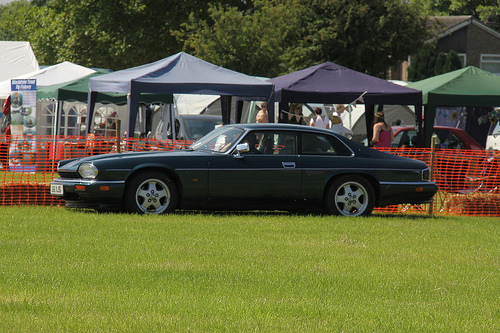<image>
Can you confirm if the orange fence is under the exotic car? No. The orange fence is not positioned under the exotic car. The vertical relationship between these objects is different. 